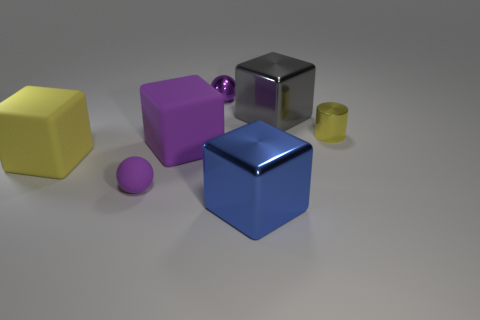Add 1 small purple things. How many objects exist? 8 Subtract all cubes. How many objects are left? 3 Add 3 small purple spheres. How many small purple spheres exist? 5 Subtract 0 green balls. How many objects are left? 7 Subtract all blue things. Subtract all yellow matte cubes. How many objects are left? 5 Add 2 large blue things. How many large blue things are left? 3 